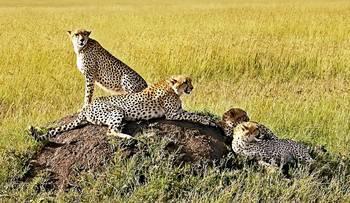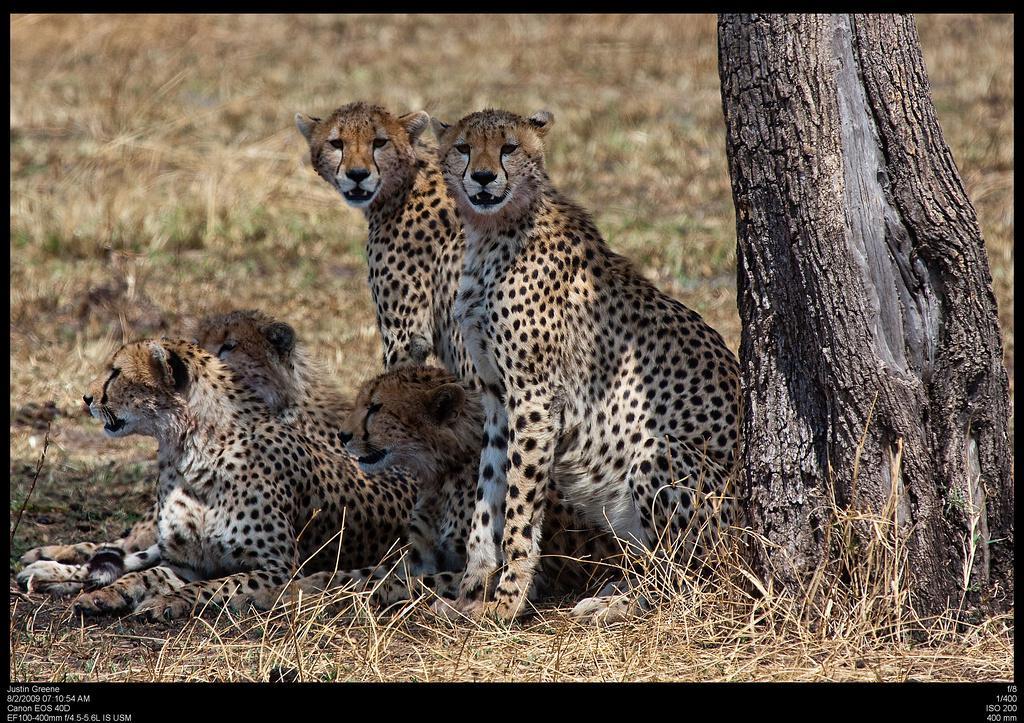The first image is the image on the left, the second image is the image on the right. Given the left and right images, does the statement "Four leopards are laying on a dirt patch in a yellow-green field in one of the images." hold true? Answer yes or no. Yes. 